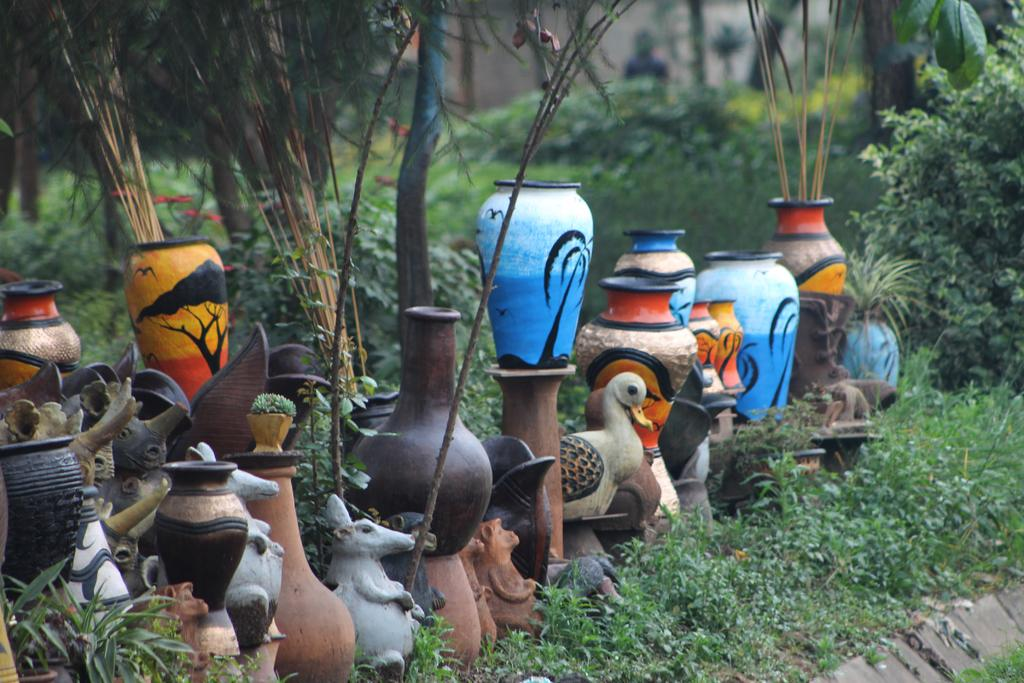What type of objects are present in the image? There are clay pots, flower vases, and animal toys in the image. Can you describe the background of the image? There are trees visible in the background of the image. What is the purpose of the air in the image? There is no mention of air in the image, so it is not possible to determine its purpose. 